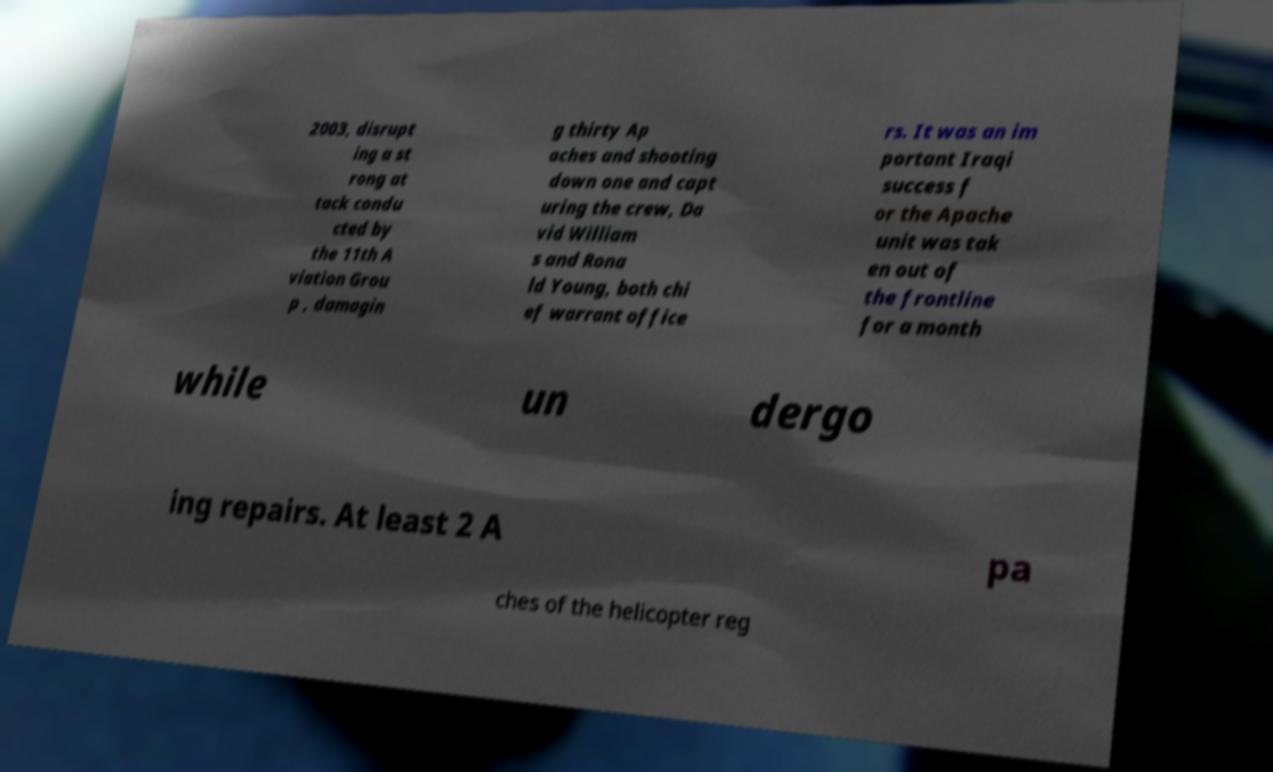Could you extract and type out the text from this image? 2003, disrupt ing a st rong at tack condu cted by the 11th A viation Grou p , damagin g thirty Ap aches and shooting down one and capt uring the crew, Da vid William s and Rona ld Young, both chi ef warrant office rs. It was an im portant Iraqi success f or the Apache unit was tak en out of the frontline for a month while un dergo ing repairs. At least 2 A pa ches of the helicopter reg 